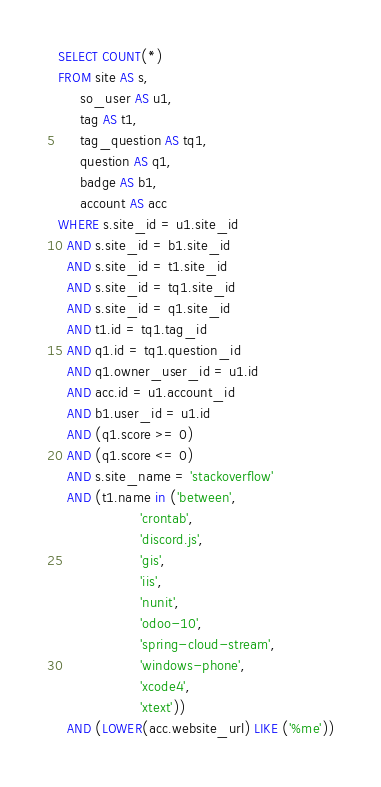Convert code to text. <code><loc_0><loc_0><loc_500><loc_500><_SQL_>SELECT COUNT(*)
FROM site AS s,
     so_user AS u1,
     tag AS t1,
     tag_question AS tq1,
     question AS q1,
     badge AS b1,
     account AS acc
WHERE s.site_id = u1.site_id
  AND s.site_id = b1.site_id
  AND s.site_id = t1.site_id
  AND s.site_id = tq1.site_id
  AND s.site_id = q1.site_id
  AND t1.id = tq1.tag_id
  AND q1.id = tq1.question_id
  AND q1.owner_user_id = u1.id
  AND acc.id = u1.account_id
  AND b1.user_id = u1.id
  AND (q1.score >= 0)
  AND (q1.score <= 0)
  AND s.site_name = 'stackoverflow'
  AND (t1.name in ('between',
                   'crontab',
                   'discord.js',
                   'gis',
                   'iis',
                   'nunit',
                   'odoo-10',
                   'spring-cloud-stream',
                   'windows-phone',
                   'xcode4',
                   'xtext'))
  AND (LOWER(acc.website_url) LIKE ('%me'))</code> 